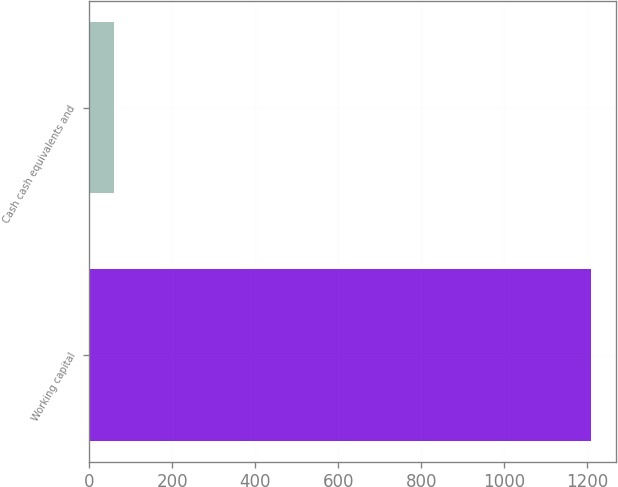Convert chart. <chart><loc_0><loc_0><loc_500><loc_500><bar_chart><fcel>Working capital<fcel>Cash cash equivalents and<nl><fcel>1210<fcel>59<nl></chart> 